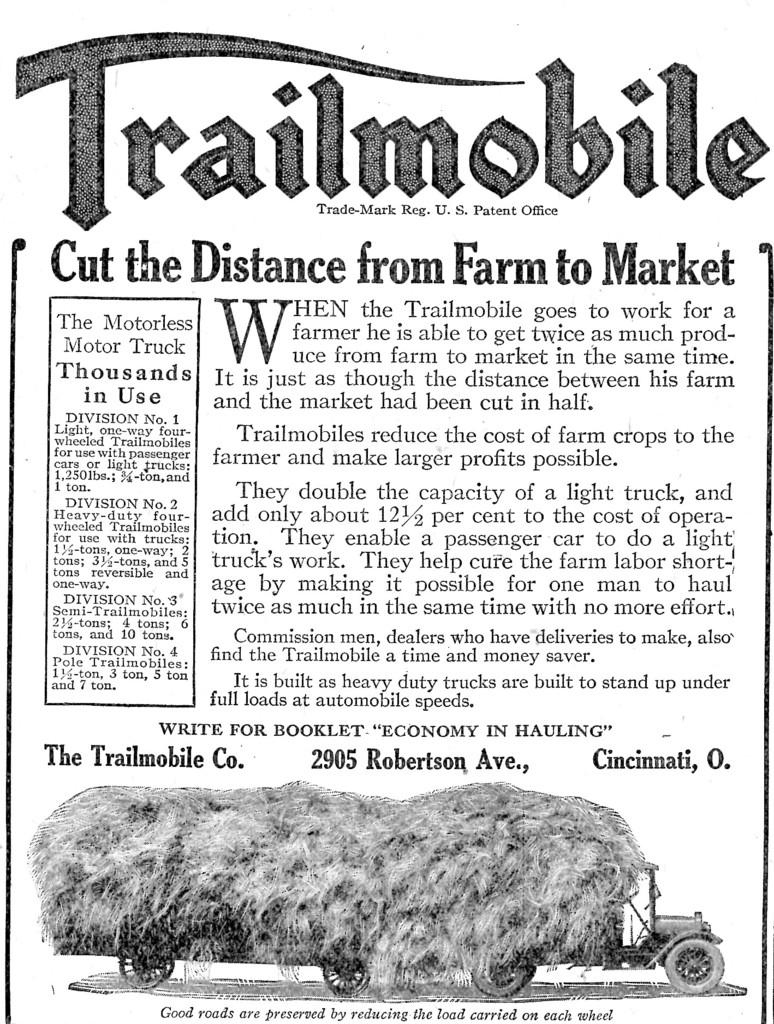What is written on the paper in the image? The paper in the image has words and numbers on it. What else can be seen in the image besides the paper? There is a vehicle in the image. Can you describe the vehicle in the image? The vehicle has grass on it. What type of mint is growing on the vehicle in the image? There is no mint growing on the vehicle in the image; it has grass on it. How many forks are visible in the image? There are no forks present in the image. 